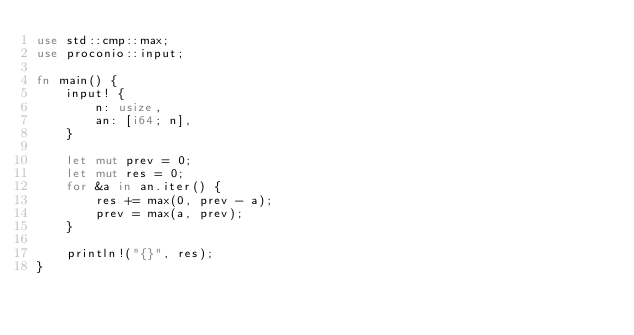<code> <loc_0><loc_0><loc_500><loc_500><_Rust_>use std::cmp::max;
use proconio::input;

fn main() {
    input! {
        n: usize,
        an: [i64; n],
    }

    let mut prev = 0;
    let mut res = 0;
    for &a in an.iter() {
        res += max(0, prev - a);
        prev = max(a, prev);
    }

    println!("{}", res);
}
</code> 